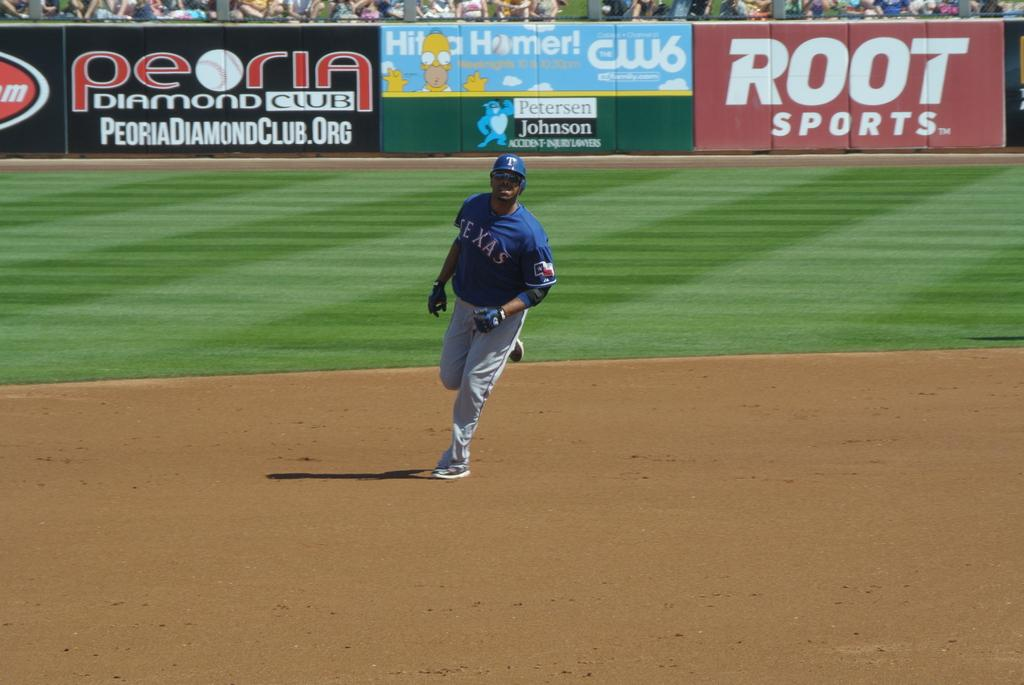<image>
Share a concise interpretation of the image provided. The Texas baseball player is between second and third base. 